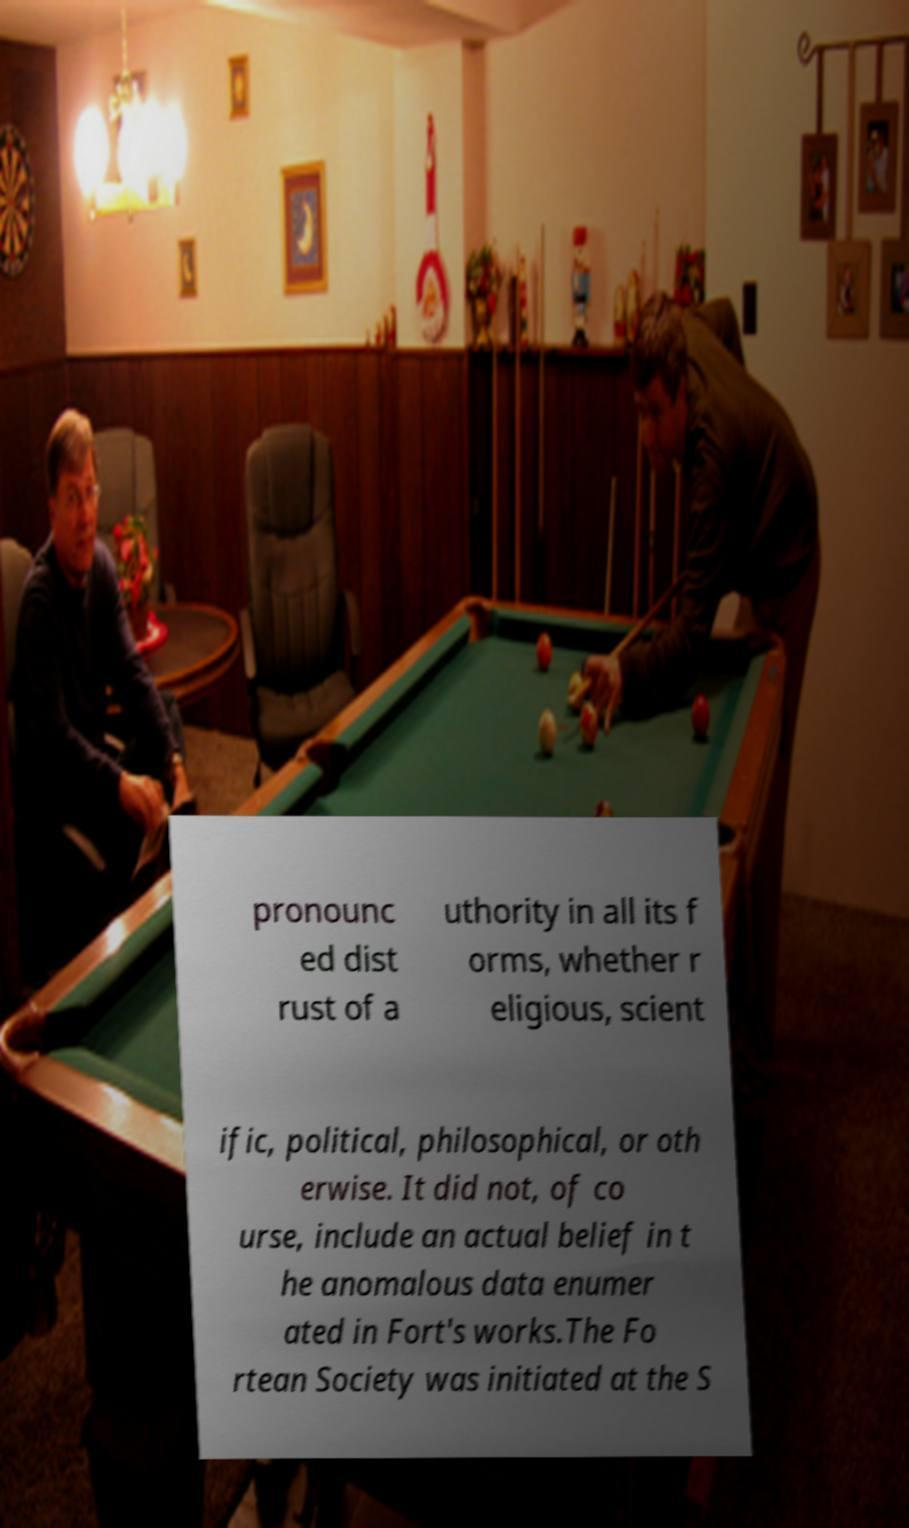Could you assist in decoding the text presented in this image and type it out clearly? pronounc ed dist rust of a uthority in all its f orms, whether r eligious, scient ific, political, philosophical, or oth erwise. It did not, of co urse, include an actual belief in t he anomalous data enumer ated in Fort's works.The Fo rtean Society was initiated at the S 